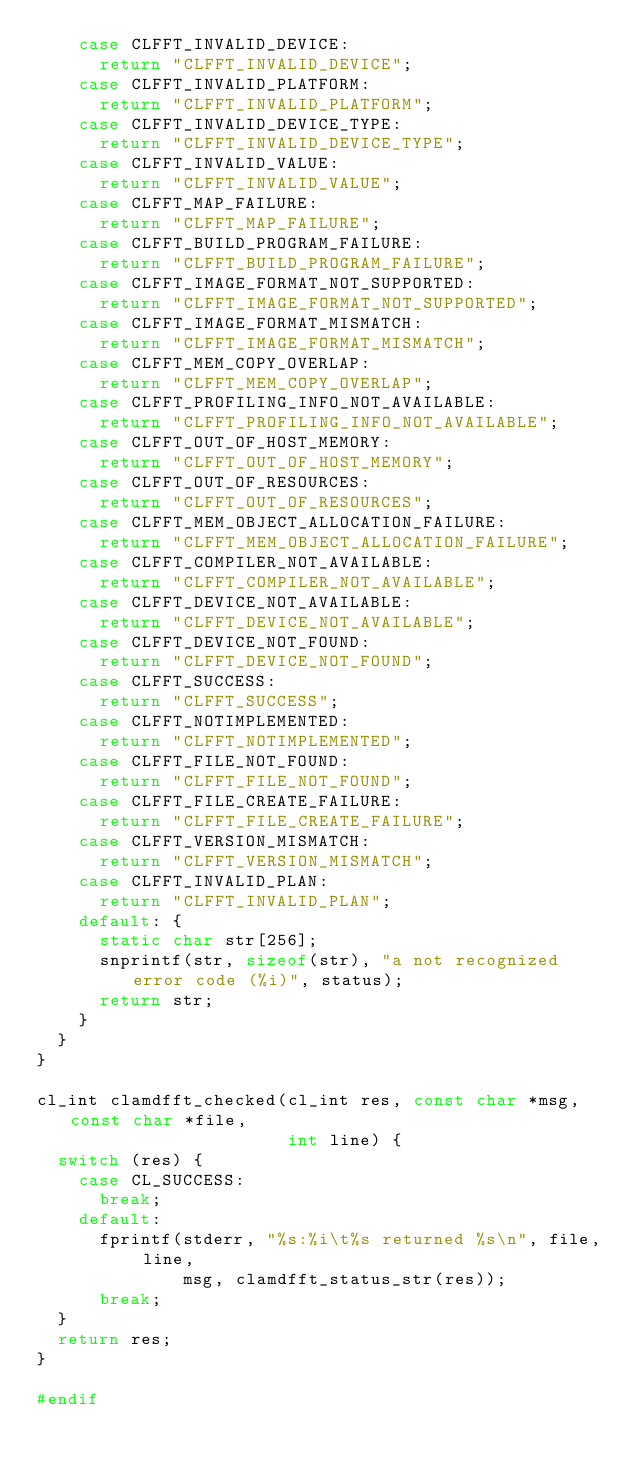Convert code to text. <code><loc_0><loc_0><loc_500><loc_500><_C_>    case CLFFT_INVALID_DEVICE:
      return "CLFFT_INVALID_DEVICE";
    case CLFFT_INVALID_PLATFORM:
      return "CLFFT_INVALID_PLATFORM";
    case CLFFT_INVALID_DEVICE_TYPE:
      return "CLFFT_INVALID_DEVICE_TYPE";
    case CLFFT_INVALID_VALUE:
      return "CLFFT_INVALID_VALUE";
    case CLFFT_MAP_FAILURE:
      return "CLFFT_MAP_FAILURE";
    case CLFFT_BUILD_PROGRAM_FAILURE:
      return "CLFFT_BUILD_PROGRAM_FAILURE";
    case CLFFT_IMAGE_FORMAT_NOT_SUPPORTED:
      return "CLFFT_IMAGE_FORMAT_NOT_SUPPORTED";
    case CLFFT_IMAGE_FORMAT_MISMATCH:
      return "CLFFT_IMAGE_FORMAT_MISMATCH";
    case CLFFT_MEM_COPY_OVERLAP:
      return "CLFFT_MEM_COPY_OVERLAP";
    case CLFFT_PROFILING_INFO_NOT_AVAILABLE:
      return "CLFFT_PROFILING_INFO_NOT_AVAILABLE";
    case CLFFT_OUT_OF_HOST_MEMORY:
      return "CLFFT_OUT_OF_HOST_MEMORY";
    case CLFFT_OUT_OF_RESOURCES:
      return "CLFFT_OUT_OF_RESOURCES";
    case CLFFT_MEM_OBJECT_ALLOCATION_FAILURE:
      return "CLFFT_MEM_OBJECT_ALLOCATION_FAILURE";
    case CLFFT_COMPILER_NOT_AVAILABLE:
      return "CLFFT_COMPILER_NOT_AVAILABLE";
    case CLFFT_DEVICE_NOT_AVAILABLE:
      return "CLFFT_DEVICE_NOT_AVAILABLE";
    case CLFFT_DEVICE_NOT_FOUND:
      return "CLFFT_DEVICE_NOT_FOUND";
    case CLFFT_SUCCESS:
      return "CLFFT_SUCCESS";
    case CLFFT_NOTIMPLEMENTED:
      return "CLFFT_NOTIMPLEMENTED";
    case CLFFT_FILE_NOT_FOUND:
      return "CLFFT_FILE_NOT_FOUND";
    case CLFFT_FILE_CREATE_FAILURE:
      return "CLFFT_FILE_CREATE_FAILURE";
    case CLFFT_VERSION_MISMATCH:
      return "CLFFT_VERSION_MISMATCH";
    case CLFFT_INVALID_PLAN:
      return "CLFFT_INVALID_PLAN";
    default: {
      static char str[256];
      snprintf(str, sizeof(str), "a not recognized error code (%i)", status);
      return str;
    }
  }
}

cl_int clamdfft_checked(cl_int res, const char *msg, const char *file,
                        int line) {
  switch (res) {
    case CL_SUCCESS:
      break;
    default:
      fprintf(stderr, "%s:%i\t%s returned %s\n", file, line,
              msg, clamdfft_status_str(res));
      break;
  }
  return res;
}

#endif
</code> 